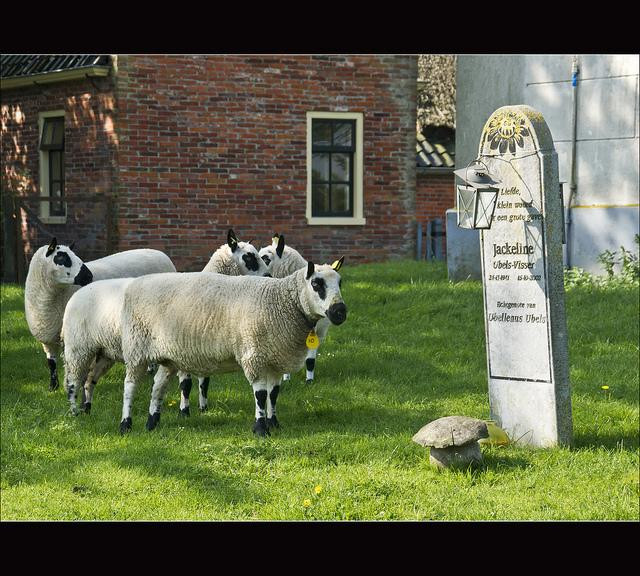What color are the patches around the eyes and noses of the sheep in this field?

Choices:
A) two
B) four
C) one
D) three four 